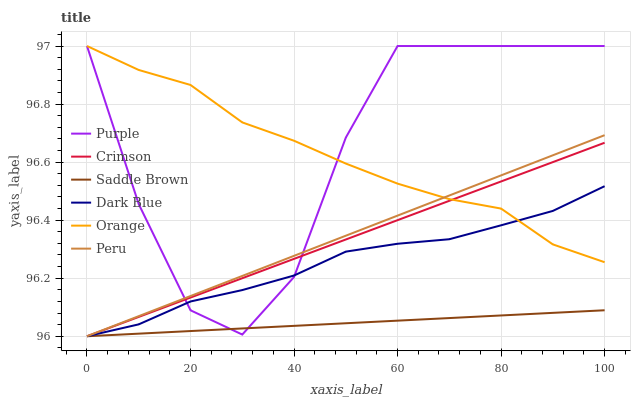Does Saddle Brown have the minimum area under the curve?
Answer yes or no. Yes. Does Purple have the maximum area under the curve?
Answer yes or no. Yes. Does Orange have the minimum area under the curve?
Answer yes or no. No. Does Orange have the maximum area under the curve?
Answer yes or no. No. Is Peru the smoothest?
Answer yes or no. Yes. Is Purple the roughest?
Answer yes or no. Yes. Is Orange the smoothest?
Answer yes or no. No. Is Orange the roughest?
Answer yes or no. No. Does Dark Blue have the lowest value?
Answer yes or no. Yes. Does Purple have the lowest value?
Answer yes or no. No. Does Orange have the highest value?
Answer yes or no. Yes. Does Peru have the highest value?
Answer yes or no. No. Is Saddle Brown less than Orange?
Answer yes or no. Yes. Is Orange greater than Saddle Brown?
Answer yes or no. Yes. Does Orange intersect Purple?
Answer yes or no. Yes. Is Orange less than Purple?
Answer yes or no. No. Is Orange greater than Purple?
Answer yes or no. No. Does Saddle Brown intersect Orange?
Answer yes or no. No. 